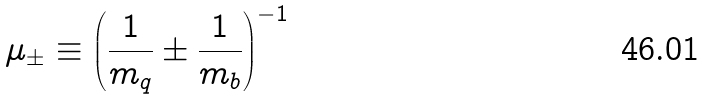<formula> <loc_0><loc_0><loc_500><loc_500>\mu _ { \pm } \equiv \left ( \frac { 1 } { m _ { q } } \pm \frac { 1 } { m _ { b } } \right ) ^ { - 1 }</formula> 